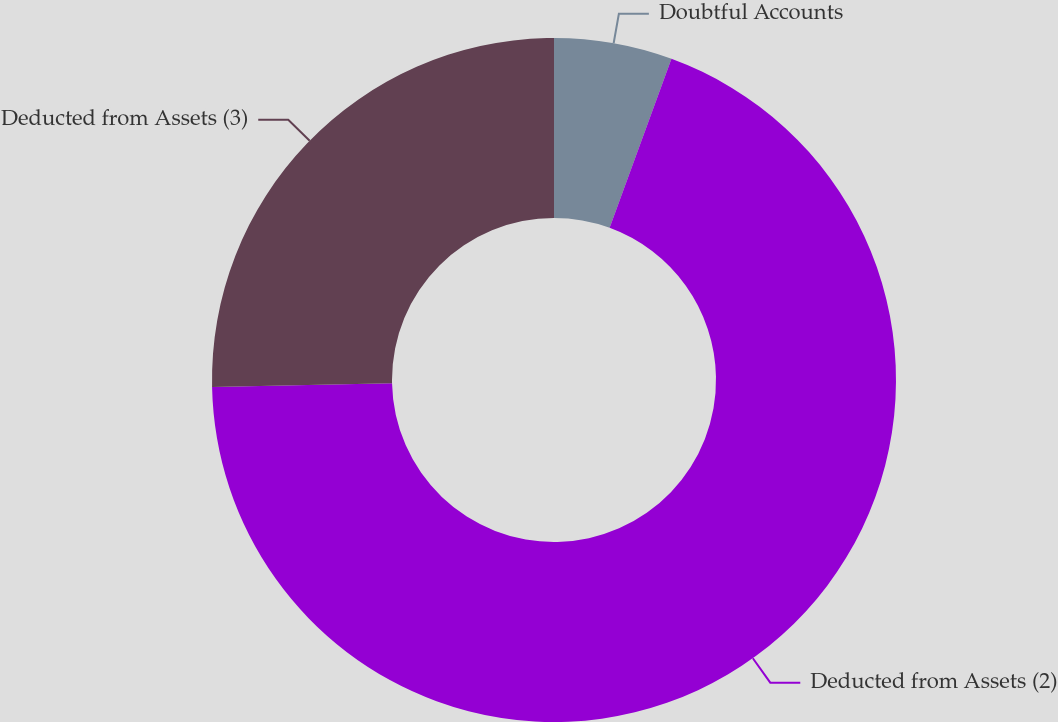<chart> <loc_0><loc_0><loc_500><loc_500><pie_chart><fcel>Doubtful Accounts<fcel>Deducted from Assets (2)<fcel>Deducted from Assets (3)<nl><fcel>5.58%<fcel>69.09%<fcel>25.33%<nl></chart> 